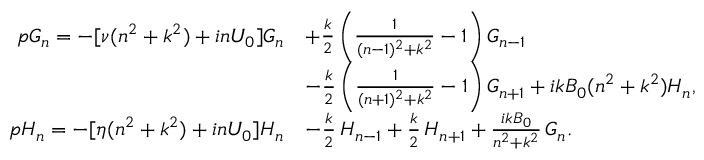Convert formula to latex. <formula><loc_0><loc_0><loc_500><loc_500>\begin{array} { r l } { p G _ { n } = - [ \nu ( n ^ { 2 } + k ^ { 2 } ) + i n U _ { 0 } ] G _ { n } } & { + \frac { k } { 2 } \left ( \frac { 1 } { ( n - 1 ) ^ { 2 } + k ^ { 2 } } - 1 \right ) G _ { n - 1 } } \\ & { - \frac { k } { 2 } \left ( \frac { 1 } { ( n + 1 ) ^ { 2 } + k ^ { 2 } } - 1 \right ) G _ { n + 1 } + i k B _ { 0 } ( n ^ { 2 } + k ^ { 2 } ) H _ { n } , } \\ { p H _ { n } = - [ \eta ( n ^ { 2 } + k ^ { 2 } ) + i n U _ { 0 } ] H _ { n } } & { - \frac { k } { 2 } \, H _ { n - 1 } + \frac { k } { 2 } \, H _ { n + 1 } + \frac { i k B _ { 0 } } { n ^ { 2 } + k ^ { 2 } } \, G _ { n } . } \end{array}</formula> 